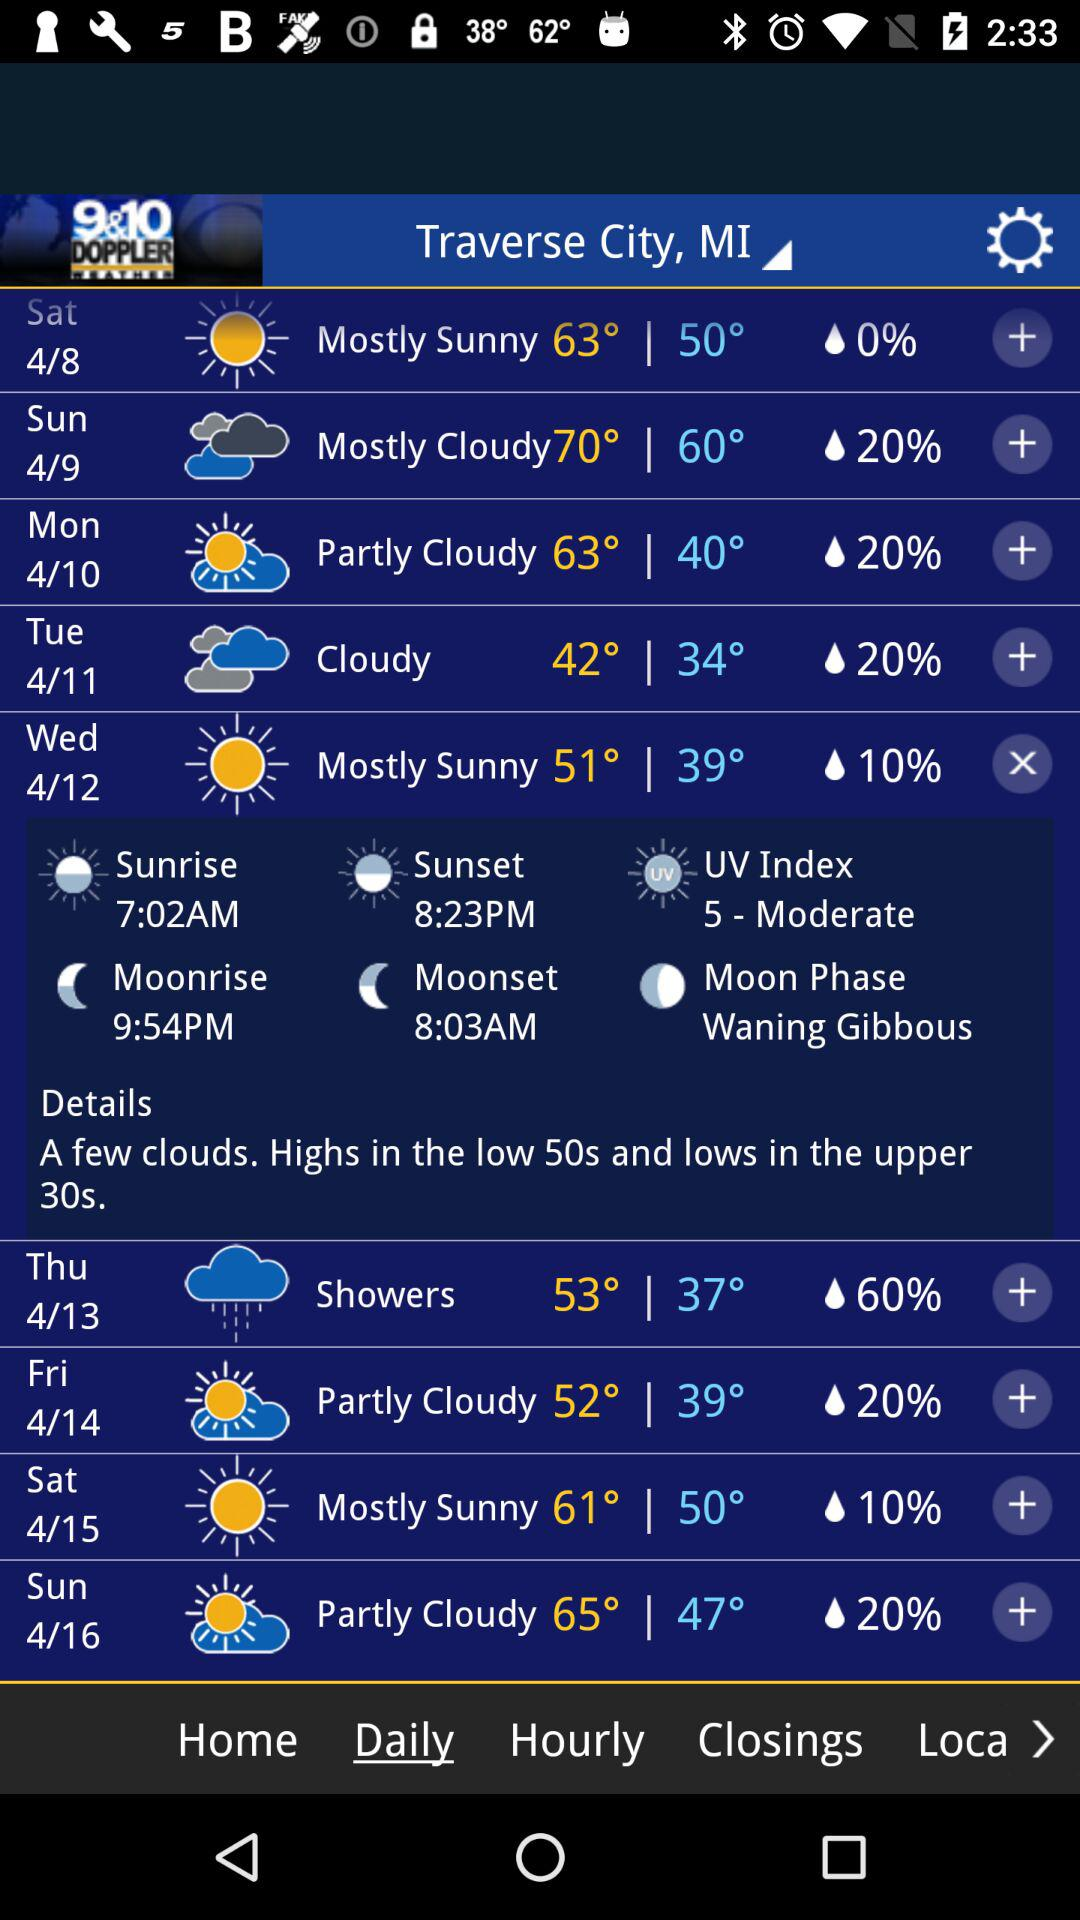What is the UV index for today?
Answer the question using a single word or phrase. 5 - Moderate 